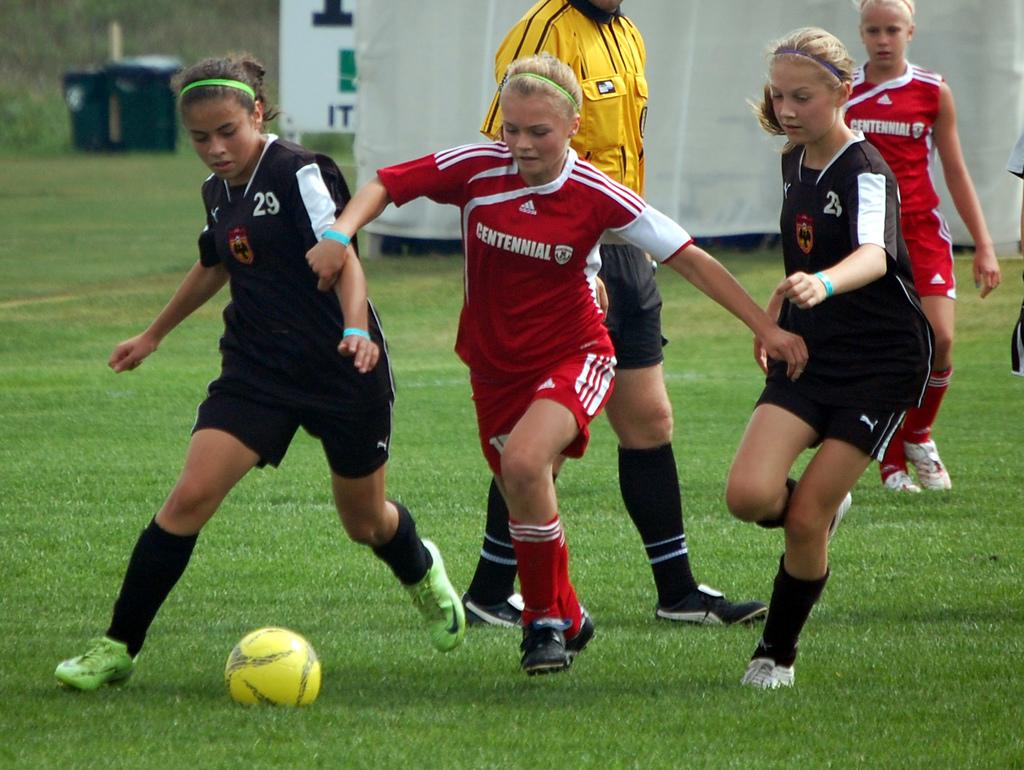What is the jersey number of the girl on the far left?
Your answer should be very brief. 29. What is the team name for the middle girl in red and white?
Provide a short and direct response. Centennial. 